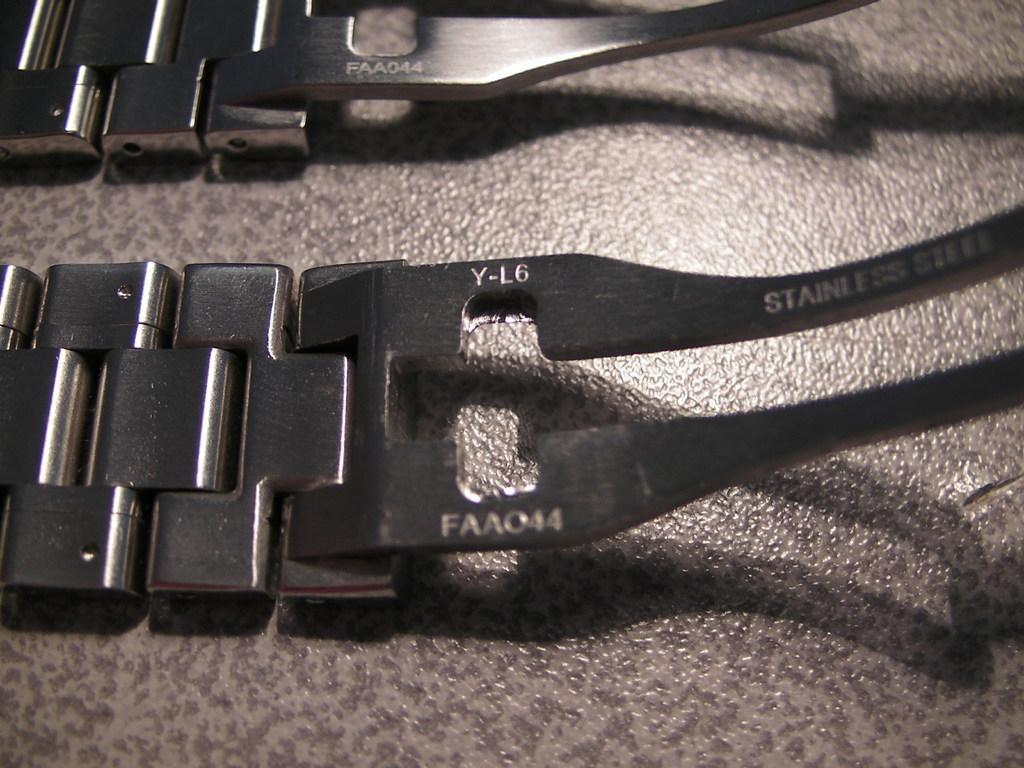Describe this image in one or two sentences. In this image we can see watch belts placed on the table. 